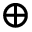<formula> <loc_0><loc_0><loc_500><loc_500>\oplus</formula> 